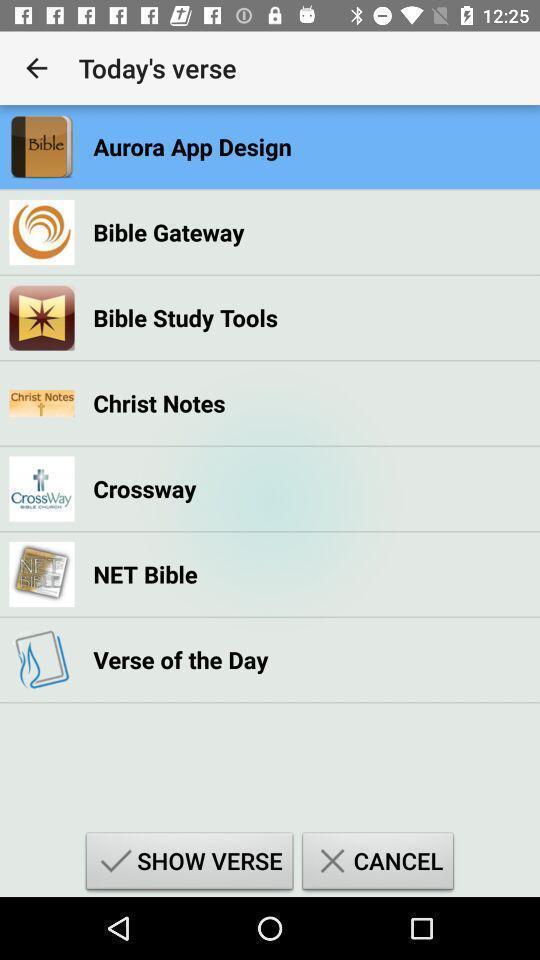Summarize the information in this screenshot. Page showing a menu in a religion based app. 